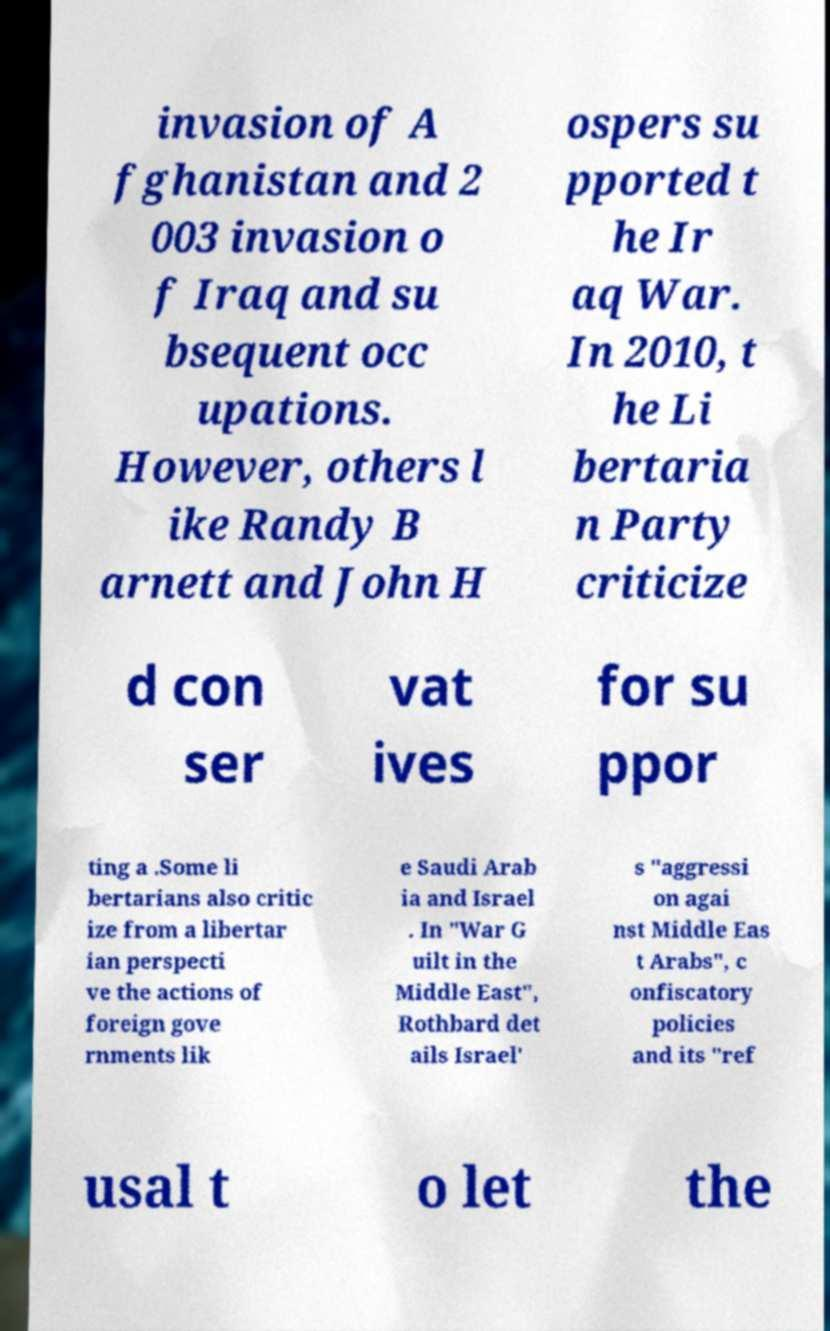For documentation purposes, I need the text within this image transcribed. Could you provide that? invasion of A fghanistan and 2 003 invasion o f Iraq and su bsequent occ upations. However, others l ike Randy B arnett and John H ospers su pported t he Ir aq War. In 2010, t he Li bertaria n Party criticize d con ser vat ives for su ppor ting a .Some li bertarians also critic ize from a libertar ian perspecti ve the actions of foreign gove rnments lik e Saudi Arab ia and Israel . In "War G uilt in the Middle East", Rothbard det ails Israel' s "aggressi on agai nst Middle Eas t Arabs", c onfiscatory policies and its "ref usal t o let the 